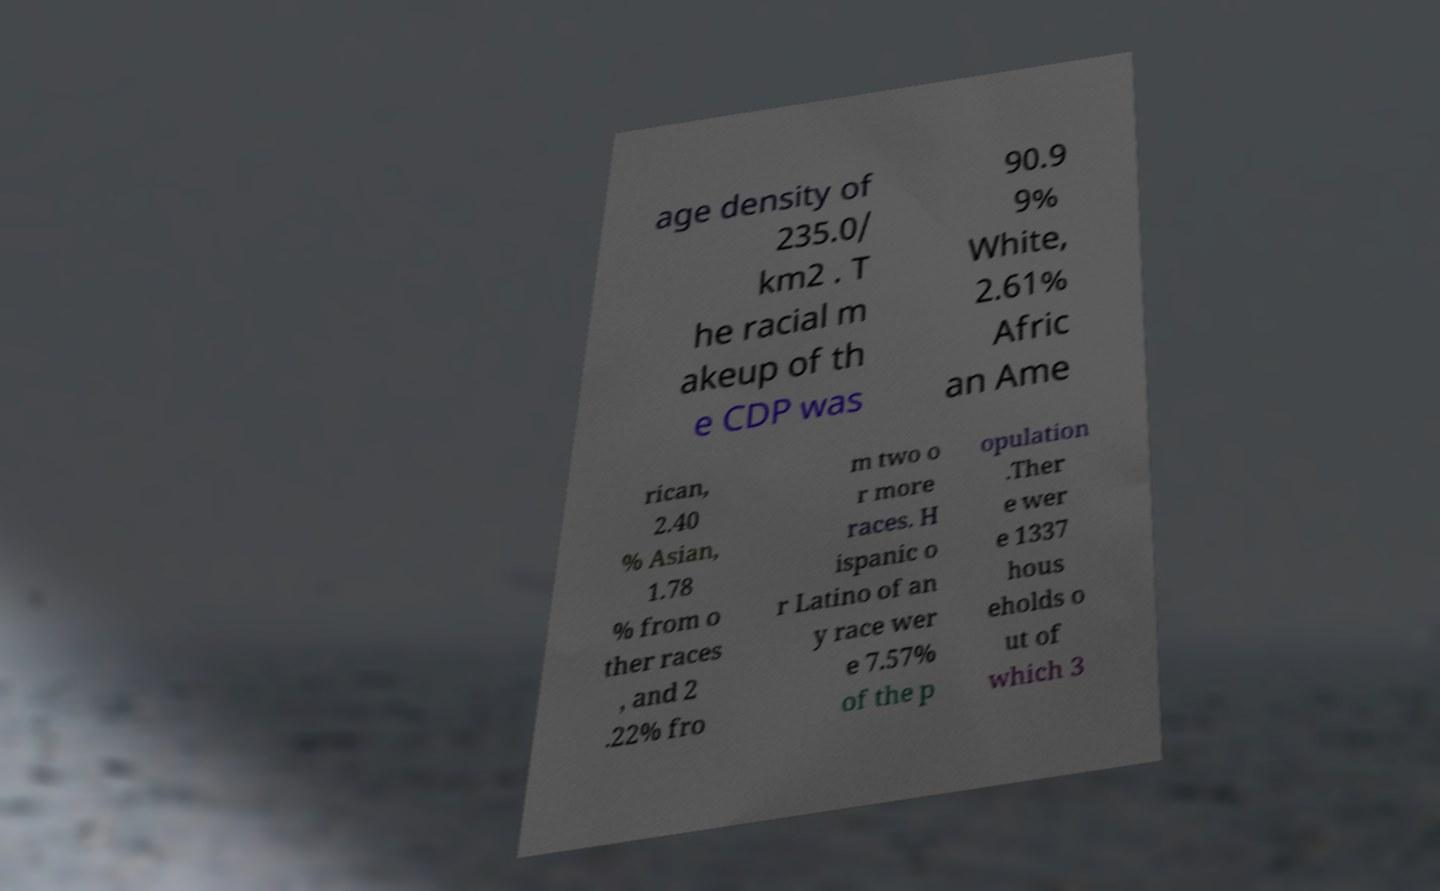I need the written content from this picture converted into text. Can you do that? age density of 235.0/ km2 . T he racial m akeup of th e CDP was 90.9 9% White, 2.61% Afric an Ame rican, 2.40 % Asian, 1.78 % from o ther races , and 2 .22% fro m two o r more races. H ispanic o r Latino of an y race wer e 7.57% of the p opulation .Ther e wer e 1337 hous eholds o ut of which 3 